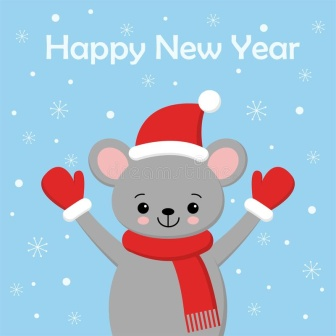What do you see happening in this image? In the image, a cheerful gray mouse is the focal point. The mouse, joyfully dressed in red mittens and a Santa hat, is raising its arms as if in celebration. A big smile brightens its face, exuding happiness and excitement. The background is a calm light blue sprinkled with white snowflakes, giving a festive and wintry feel. Above the mouse, in bold white script, is the greeting 'Happy New Year', adding an extra layer of festivity to the scene. The positioning of the mouse, the scattered snowflakes, and the festive greeting come together harmoniously to create an uplifting New Year's greeting. 